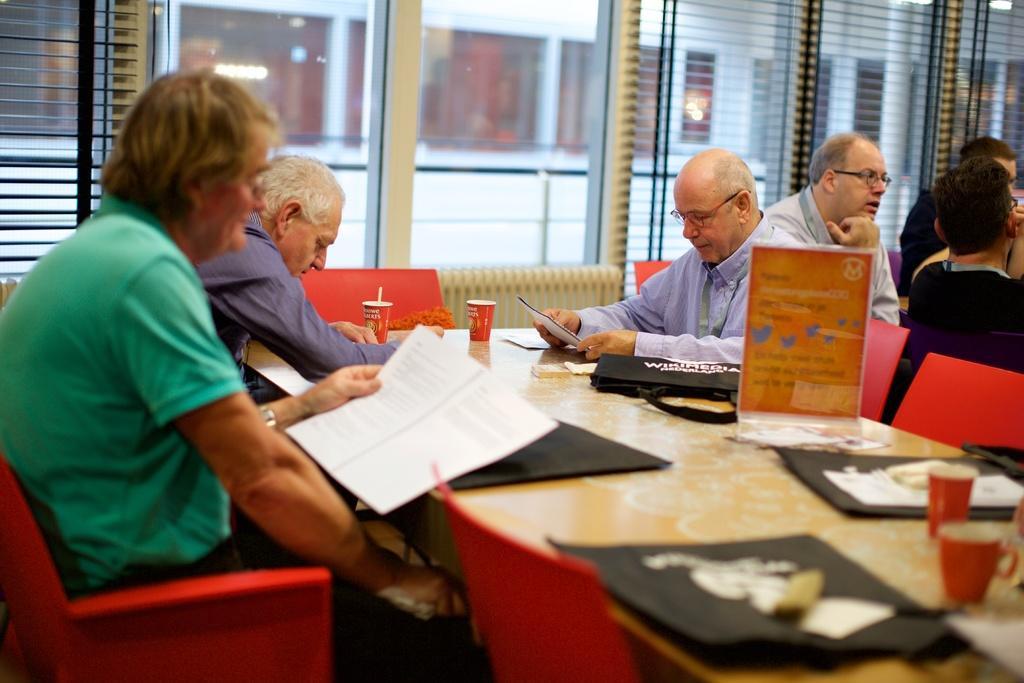Describe this image in one or two sentences. In this image two persons are sitting left side of the image and four people are sitting right side of image. There is a table having cups and bag and poster on table. Left side person is holding a book. Background there is window from which building is visible. 